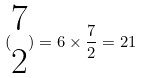<formula> <loc_0><loc_0><loc_500><loc_500>( \begin{matrix} 7 \\ 2 \end{matrix} ) = 6 \times \frac { 7 } { 2 } = 2 1</formula> 